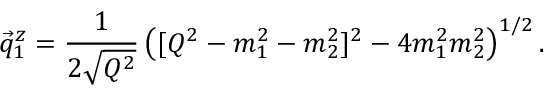Convert formula to latex. <formula><loc_0><loc_0><loc_500><loc_500>\vec { q } _ { 1 } ^ { z } = \frac { 1 } { 2 \sqrt { Q ^ { 2 } } } \left ( [ Q ^ { 2 } - m _ { 1 } ^ { 2 } - m _ { 2 } ^ { 2 } ] ^ { 2 } - 4 m _ { 1 } ^ { 2 } m _ { 2 } ^ { 2 } \right ) ^ { 1 / 2 } .</formula> 